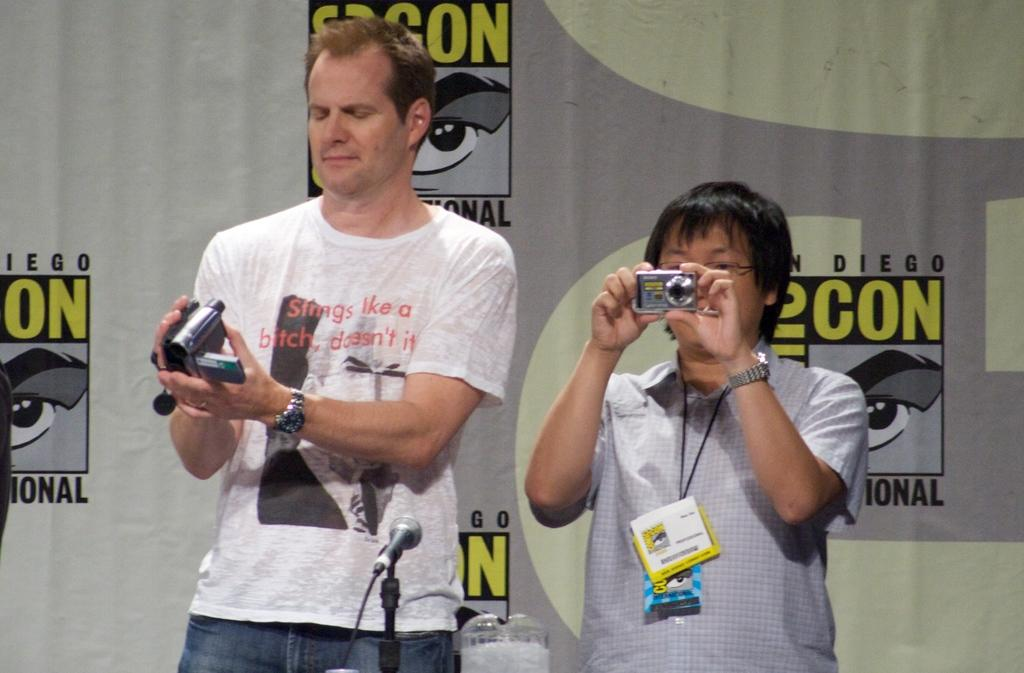How many people are in the image? There are two men in the picture. What are the men holding in their hands? The men are holding cameras in their hands. Can you describe any other objects in the image? There is a microphone in the bottom of the picture. What can be seen in the background of the image? There is a flex in the background of the picture. How many stamps are visible on the men's clothing in the image? There are no stamps visible on the men's clothing in the image. Can you tell me how many snakes are slithering around the microphone in the image? There are no snakes present in the image; only the microphone and the two men holding cameras are visible. 